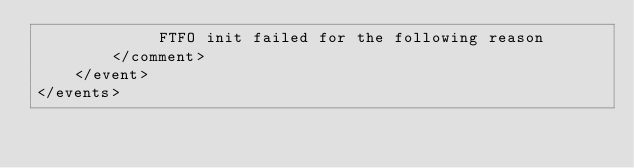Convert code to text. <code><loc_0><loc_0><loc_500><loc_500><_XML_>             FTFO init failed for the following reason
        </comment>
    </event>
</events>
</code> 